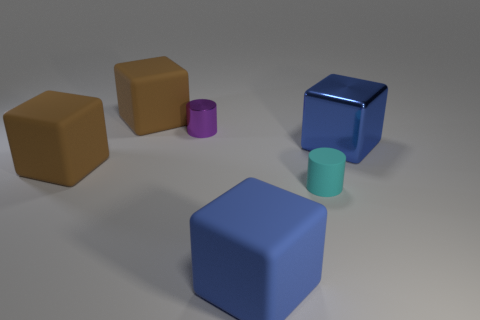What is the size of the blue block that is made of the same material as the small purple cylinder?
Make the answer very short. Large. There is a shiny object that is in front of the purple metallic thing; is its size the same as the small purple thing?
Your answer should be very brief. No. The large rubber object on the right side of the large brown object that is behind the large object that is to the right of the small rubber cylinder is what shape?
Ensure brevity in your answer.  Cube. How many objects are either tiny shiny cylinders or objects behind the tiny cyan object?
Make the answer very short. 4. What size is the shiny object to the right of the purple cylinder?
Keep it short and to the point. Large. There is a large matte object that is the same color as the shiny block; what shape is it?
Offer a terse response. Cube. Are the purple cylinder and the tiny cylinder that is right of the small purple cylinder made of the same material?
Make the answer very short. No. What number of big brown rubber cubes are in front of the blue cube behind the brown matte cube in front of the small metal thing?
Offer a terse response. 1. How many blue objects are either shiny things or big matte things?
Keep it short and to the point. 2. The large brown thing behind the small purple object has what shape?
Provide a succinct answer. Cube. 